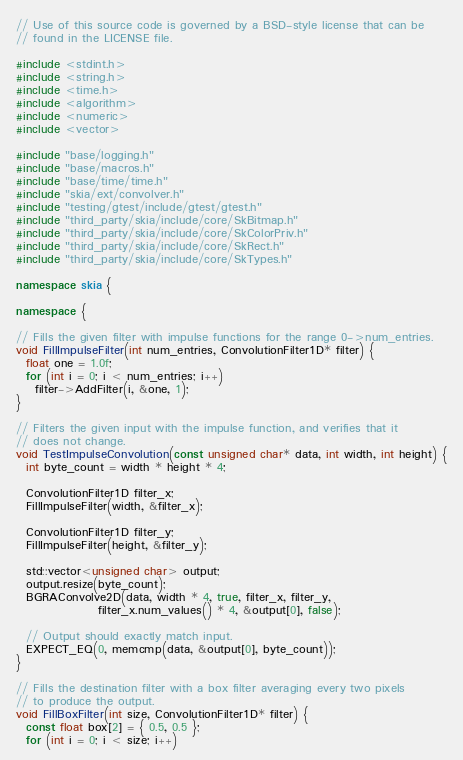Convert code to text. <code><loc_0><loc_0><loc_500><loc_500><_C++_>// Use of this source code is governed by a BSD-style license that can be
// found in the LICENSE file.

#include <stdint.h>
#include <string.h>
#include <time.h>
#include <algorithm>
#include <numeric>
#include <vector>

#include "base/logging.h"
#include "base/macros.h"
#include "base/time/time.h"
#include "skia/ext/convolver.h"
#include "testing/gtest/include/gtest/gtest.h"
#include "third_party/skia/include/core/SkBitmap.h"
#include "third_party/skia/include/core/SkColorPriv.h"
#include "third_party/skia/include/core/SkRect.h"
#include "third_party/skia/include/core/SkTypes.h"

namespace skia {

namespace {

// Fills the given filter with impulse functions for the range 0->num_entries.
void FillImpulseFilter(int num_entries, ConvolutionFilter1D* filter) {
  float one = 1.0f;
  for (int i = 0; i < num_entries; i++)
    filter->AddFilter(i, &one, 1);
}

// Filters the given input with the impulse function, and verifies that it
// does not change.
void TestImpulseConvolution(const unsigned char* data, int width, int height) {
  int byte_count = width * height * 4;

  ConvolutionFilter1D filter_x;
  FillImpulseFilter(width, &filter_x);

  ConvolutionFilter1D filter_y;
  FillImpulseFilter(height, &filter_y);

  std::vector<unsigned char> output;
  output.resize(byte_count);
  BGRAConvolve2D(data, width * 4, true, filter_x, filter_y,
                 filter_x.num_values() * 4, &output[0], false);

  // Output should exactly match input.
  EXPECT_EQ(0, memcmp(data, &output[0], byte_count));
}

// Fills the destination filter with a box filter averaging every two pixels
// to produce the output.
void FillBoxFilter(int size, ConvolutionFilter1D* filter) {
  const float box[2] = { 0.5, 0.5 };
  for (int i = 0; i < size; i++)</code> 